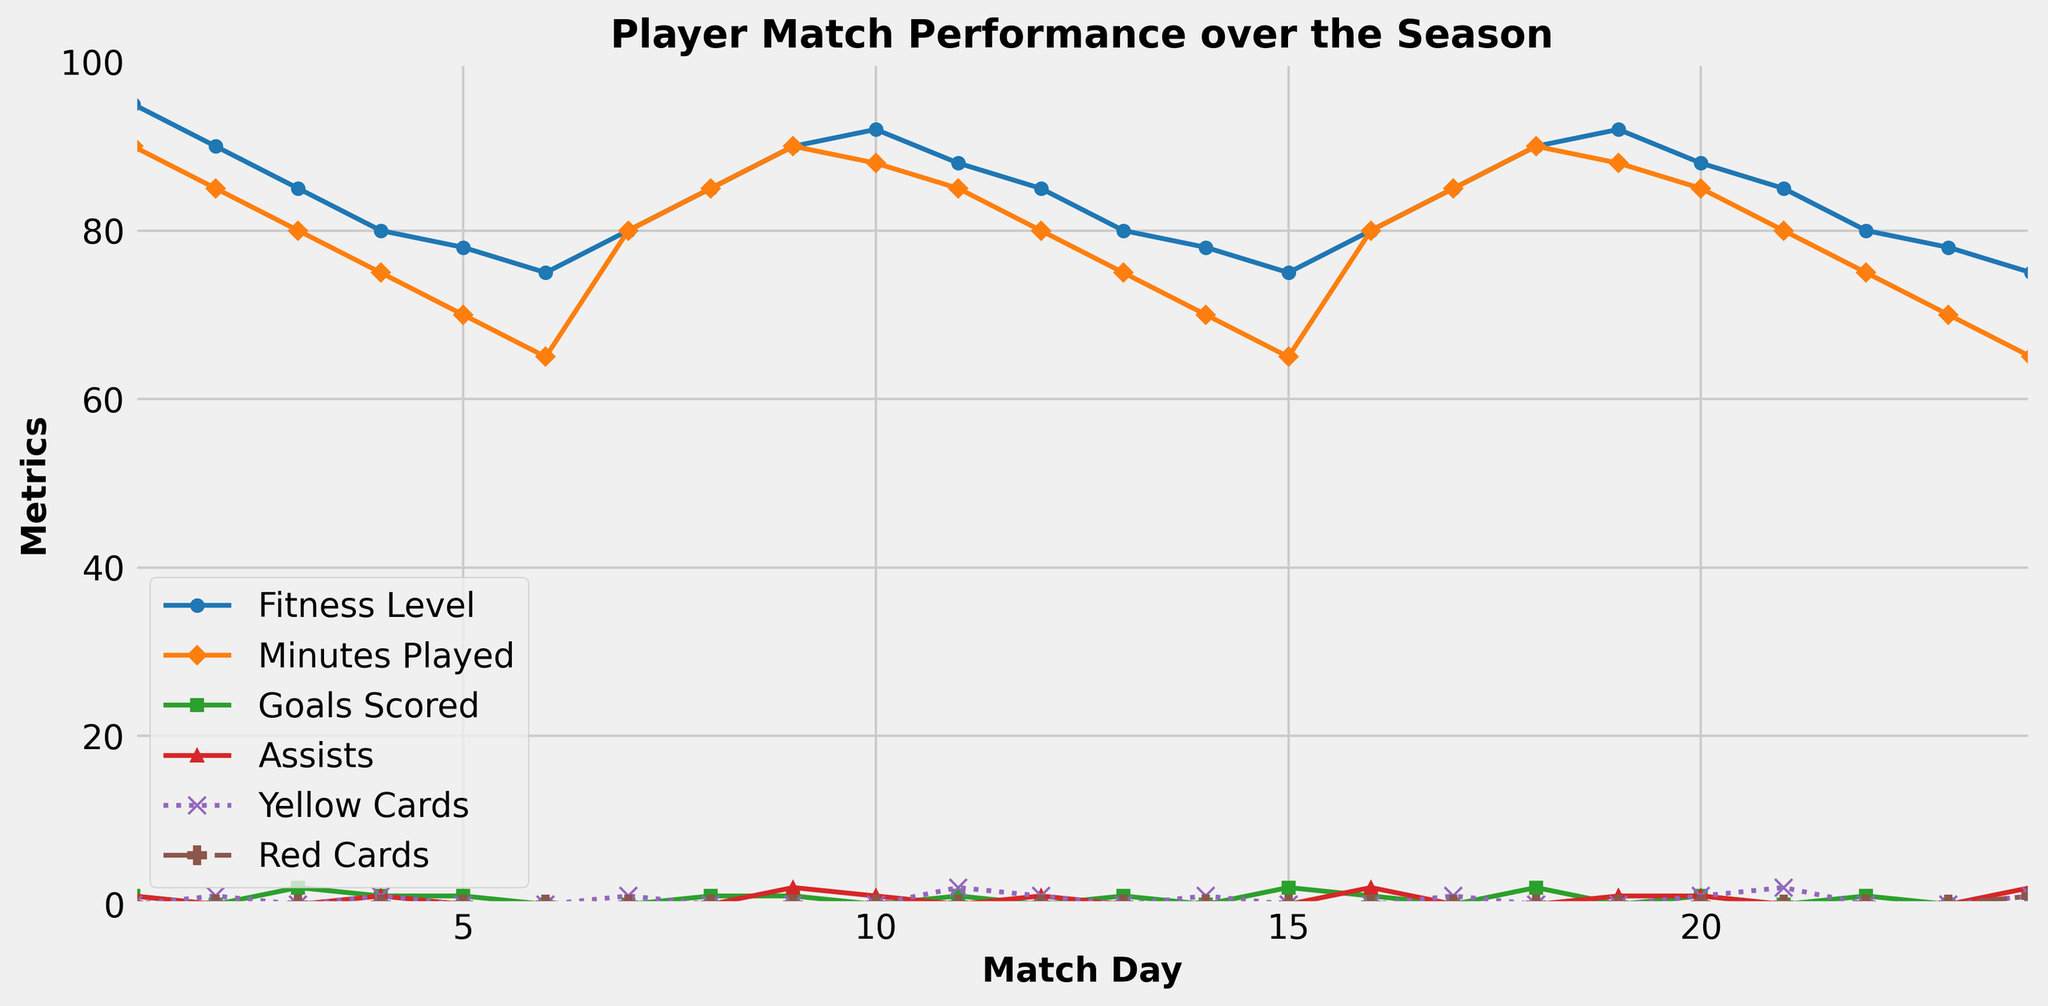What is the highest fitness level recorded during the season? Look for the highest point on the Fitness Level curve, which is at 95 on match day 1.
Answer: 95 On which match day did the player score the most goals? Check the highest point on the Goals Scored curve, which is 2 goals on match days 3, 15, and 18.
Answer: 3, 15, 18 What is the average fitness level over the first five match days? Sum the fitness levels for match days 1 to 5 (95 + 90 + 85 + 80 + 78 = 428) and divide by 5, which results in 85.6.
Answer: 85.6 Compare the fitness level and the minutes played on match day 10. Are they equal? Observe the curves for match day 10, where the fitness level is 92 and minutes played is 88. They are not equal.
Answer: No On which match days did the player get red carded? Observe the points on the Red Cards curve; the player received red cards on match days 12 and 24.
Answer: 12, 24 What is the sum of assists and yellow cards on match day 9? Check the points for assists and yellow cards on match day 9 (2 assists + 0 yellow cards = 2).
Answer: 2 Was the player's fitness level above or below 80 on match day 16? Check the Fitness Level curve for match day 16, which shows a fitness level of 80, meaning it is equal to 80, rather than above or below.
Answer: Equal How does the fitness level trend compare between match days 1 and 24? Observe the trend on the Fitness Level curve; it starts at 95 on match day 1 and drops to 75 by match day 24, indicating a decline.
Answer: Declined What's the difference in fitness level between match days 6 and 18? Subtract the fitness level on match day 6 (75) from that on match day 18 (90) to get the difference, which is 15.
Answer: 15 How many yellow cards did the player receive between match days 10 and 20? Sum the yellow cards from match days 10 to 20 (0 + 2 + 1 + 0 + 1 + 1 + 0 + 1 + 1 + 0 + 1 = 8).
Answer: 8 